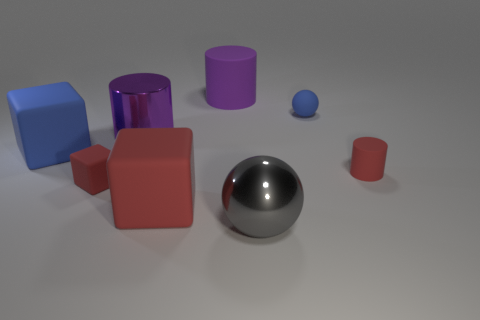Subtract all big metal cylinders. How many cylinders are left? 2 Add 1 tiny cylinders. How many objects exist? 9 Subtract all red cubes. How many cubes are left? 1 Subtract all gray spheres. How many purple cylinders are left? 2 Subtract all cylinders. How many objects are left? 5 Subtract 1 cylinders. How many cylinders are left? 2 Subtract all brown cubes. Subtract all purple balls. How many cubes are left? 3 Subtract all red things. Subtract all big purple rubber things. How many objects are left? 4 Add 8 red cylinders. How many red cylinders are left? 9 Add 5 large blue cubes. How many large blue cubes exist? 6 